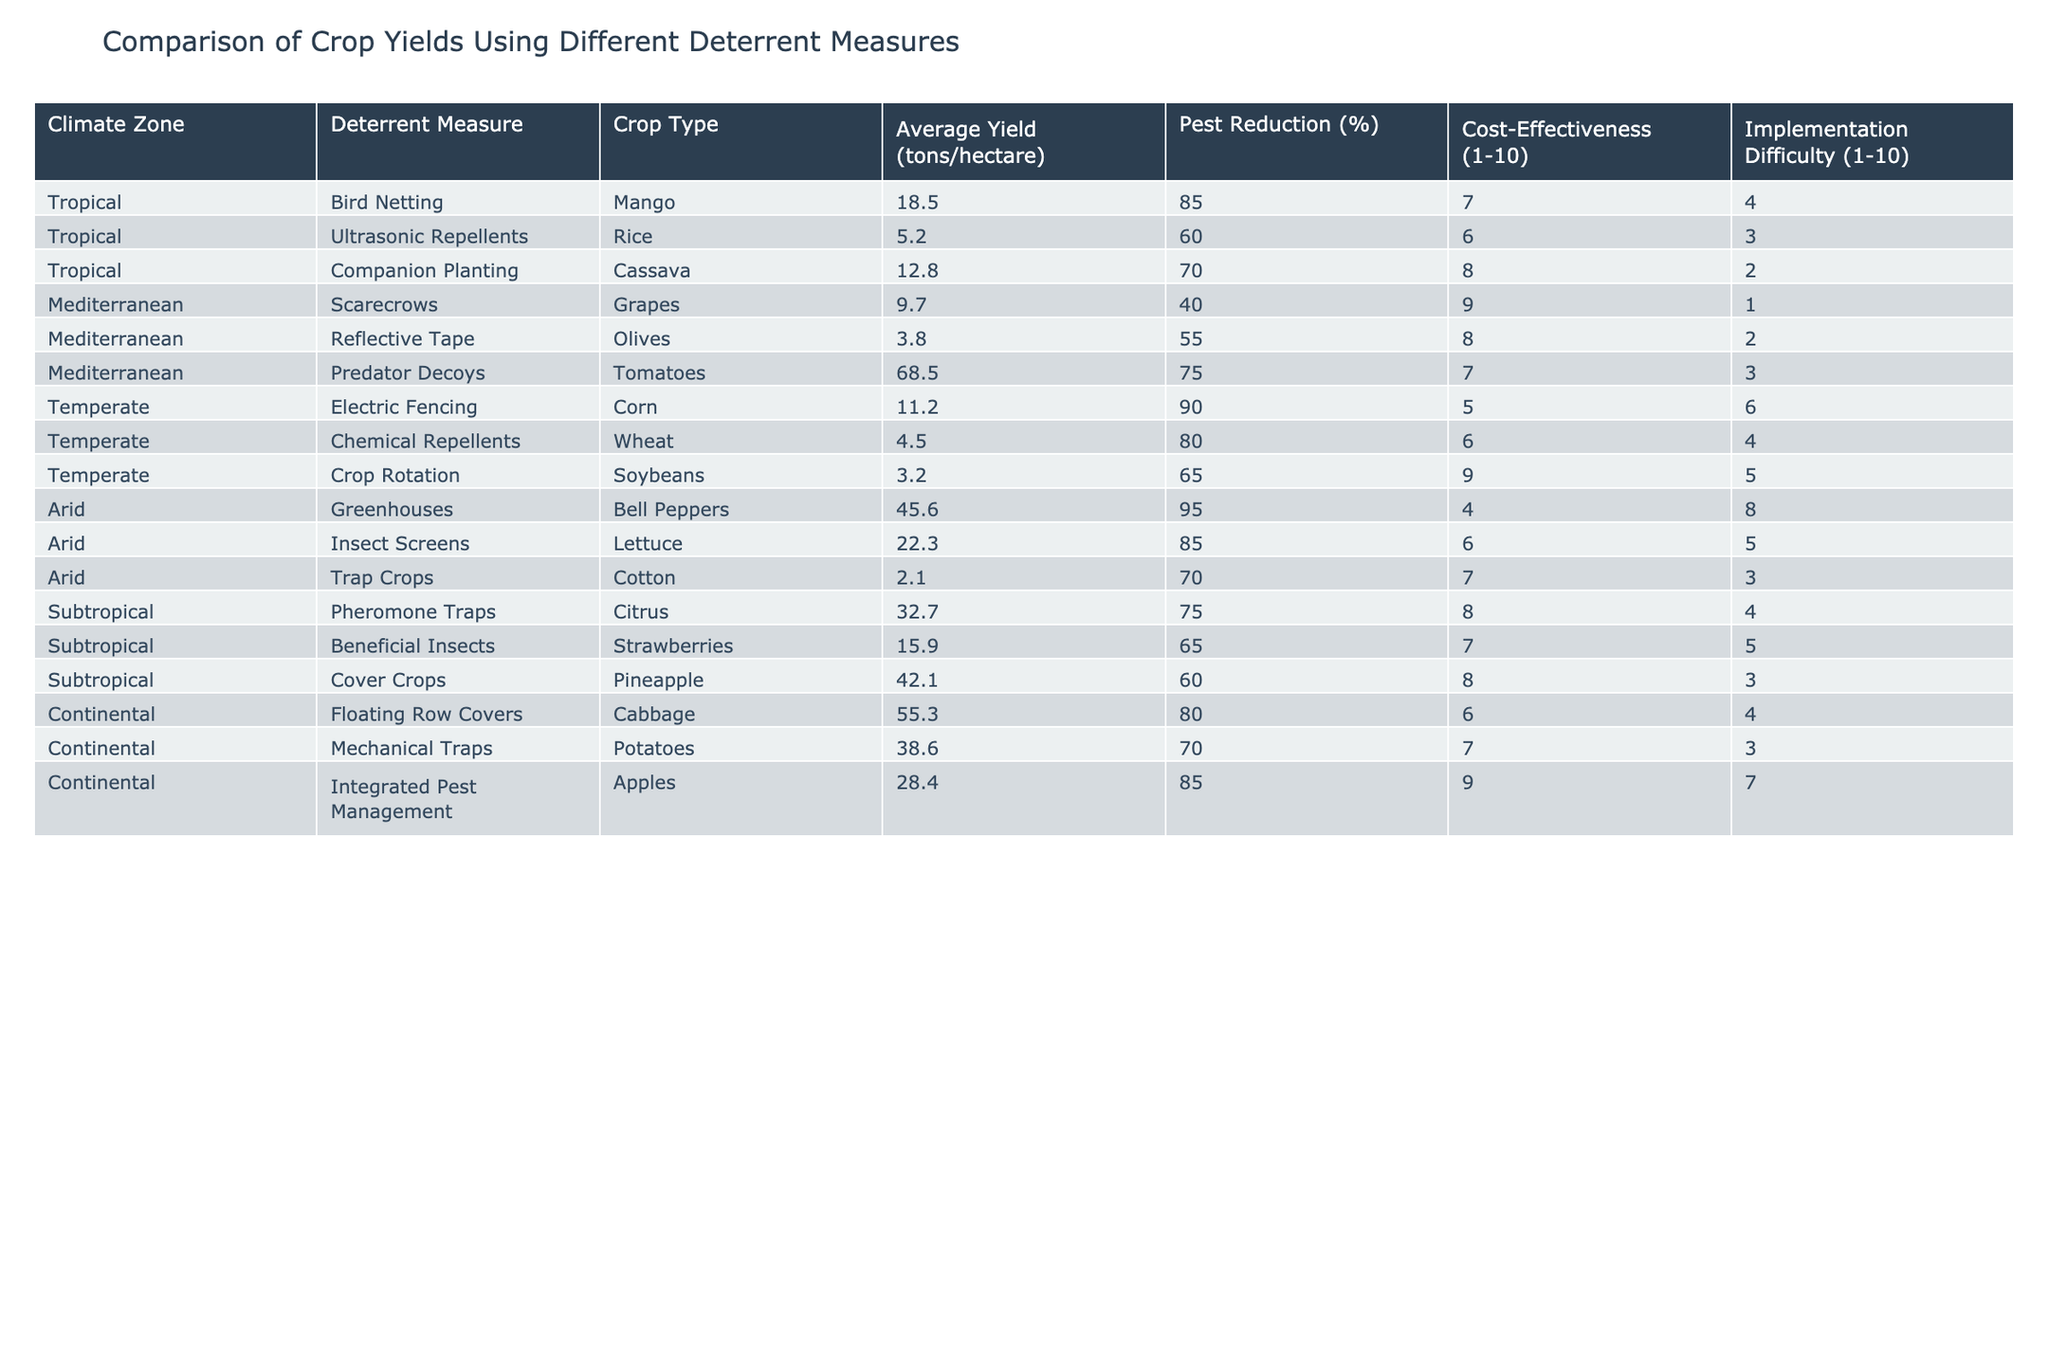What crop type has the highest average yield using deterrent measures? Looking through the table, the average yield values indicate that tomatoes, with the deterrent measure of predator decoys, have the highest yield at 68.5 tons/hectare.
Answer: Tomatoes Which deterrent measure shows the highest pest reduction percentage in the tropical climate zone? In the tropical climate zone, bird netting has the highest pest reduction at 85%. This is confirmed by checking the pest reduction values for each deterrent measure under the tropical category.
Answer: Bird Netting What is the average yield for crops protected by crop rotation? In the table, the yield for crop rotation (soybeans) is 3.2 tons/hectare, as it is the only crop type listed under that deterrent measure. Thus, the average yield is simply 3.2 tons/hectare.
Answer: 3.2 Is electric fencing the most cost-effective deterrent measure in the temperate zone? Evaluating the cost-effectiveness scores for all deterrent measures in the temperate zone, electric fencing has a score of 5, which is lower than the scores for chemical repellents (6) and crop rotation (9). Therefore, it is not the most cost-effective.
Answer: No What is the total average yield of crops using beneficial insects and pheromone traps in subtropical climate zones? The average yields for beneficial insects (15.9 tons/hectare) and pheromone traps (32.7 tons/hectare) need to be summed up. Therefore, the total average yield is 15.9 + 32.7 = 48.6 tons/hectare.
Answer: 48.6 Which deterrent measure in the Mediterranean climate zone has the lowest average yield? Scanning the Mediterranean climate zone, reflective tape shows the lowest yield at 3.8 tons/hectare when compared to scarecrows (9.7) and predator decoys (68.5).
Answer: Reflective Tape Are the average yields for crops using traps (mechanical traps and pheromone traps) higher than those using chemical repellents? The average yield using mechanical traps is 38.6 tons/hectare and pheromone traps (in subtropical) is 32.7 tons/hectare. The yield for chemical repellents (4.5 tons/hectare) is much lower. Therefore, both traps yield higher overall.
Answer: Yes What is the implementation difficulty rating for predator decoys and how does it compare to bird netting? Predator decoys have an implementation difficulty rating of 3 while bird netting has a rating of 4. This means predator decoys are easier to implement compared to bird netting.
Answer: 3 (predator decoys are easier) 